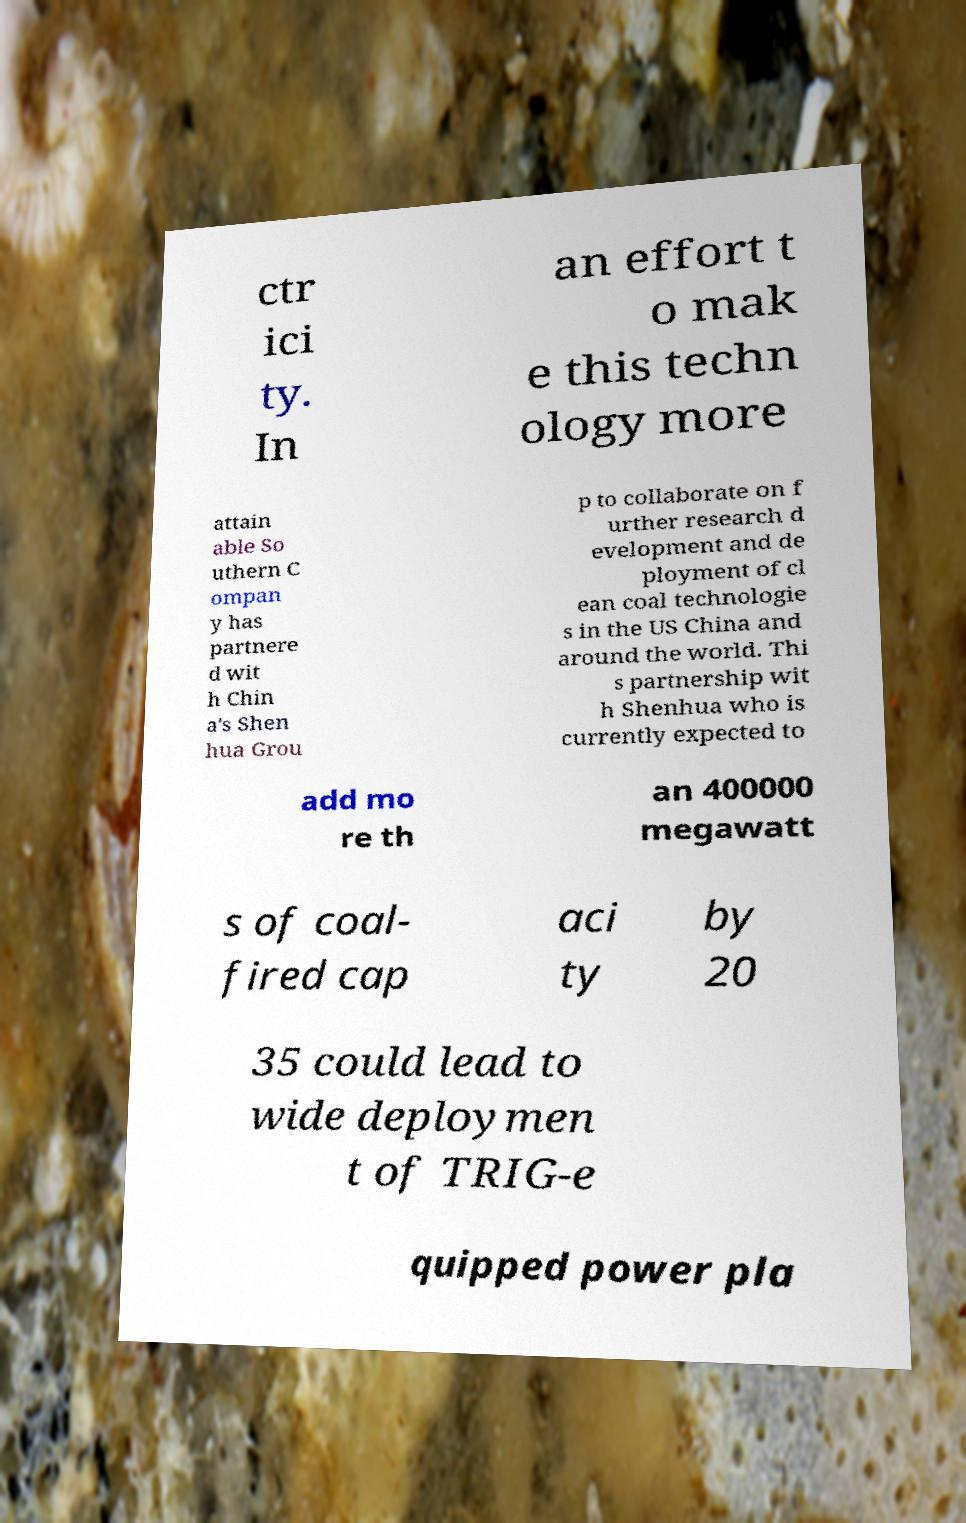There's text embedded in this image that I need extracted. Can you transcribe it verbatim? ctr ici ty. In an effort t o mak e this techn ology more attain able So uthern C ompan y has partnere d wit h Chin a's Shen hua Grou p to collaborate on f urther research d evelopment and de ployment of cl ean coal technologie s in the US China and around the world. Thi s partnership wit h Shenhua who is currently expected to add mo re th an 400000 megawatt s of coal- fired cap aci ty by 20 35 could lead to wide deploymen t of TRIG-e quipped power pla 